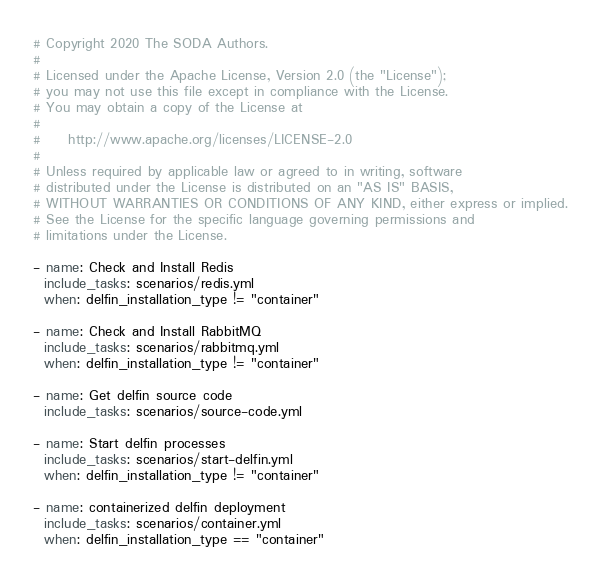Convert code to text. <code><loc_0><loc_0><loc_500><loc_500><_YAML_># Copyright 2020 The SODA Authors.
#
# Licensed under the Apache License, Version 2.0 (the "License");
# you may not use this file except in compliance with the License.
# You may obtain a copy of the License at
#
#     http://www.apache.org/licenses/LICENSE-2.0
#
# Unless required by applicable law or agreed to in writing, software
# distributed under the License is distributed on an "AS IS" BASIS,
# WITHOUT WARRANTIES OR CONDITIONS OF ANY KIND, either express or implied.
# See the License for the specific language governing permissions and
# limitations under the License.

- name: Check and Install Redis
  include_tasks: scenarios/redis.yml
  when: delfin_installation_type != "container"

- name: Check and Install RabbitMQ
  include_tasks: scenarios/rabbitmq.yml
  when: delfin_installation_type != "container"

- name: Get delfin source code
  include_tasks: scenarios/source-code.yml

- name: Start delfin processes
  include_tasks: scenarios/start-delfin.yml
  when: delfin_installation_type != "container"

- name: containerized delfin deployment
  include_tasks: scenarios/container.yml
  when: delfin_installation_type == "container"
</code> 